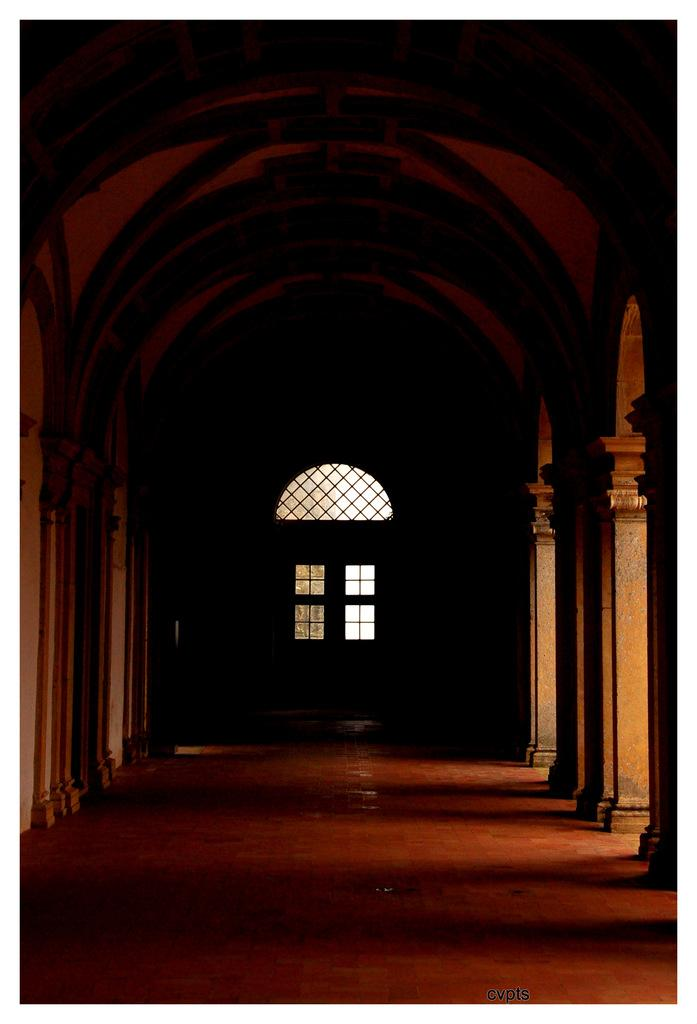What is at the bottom of the image? There is a floor at the bottom of the image. What can be seen on the left side of the image? There are pillars on the left side of the image. What can be seen on the right side of the image? There are pillars on the right side of the image. What is in the middle of the image? There is a window in the middle of the image. Where is the cup placed in the image? There is no cup present in the image. What type of lamp can be seen in the image? There is no lamp present in the image. 